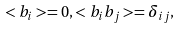<formula> <loc_0><loc_0><loc_500><loc_500>< b _ { i } > = 0 , < b _ { i } b _ { j } > = \delta _ { i j } ,</formula> 